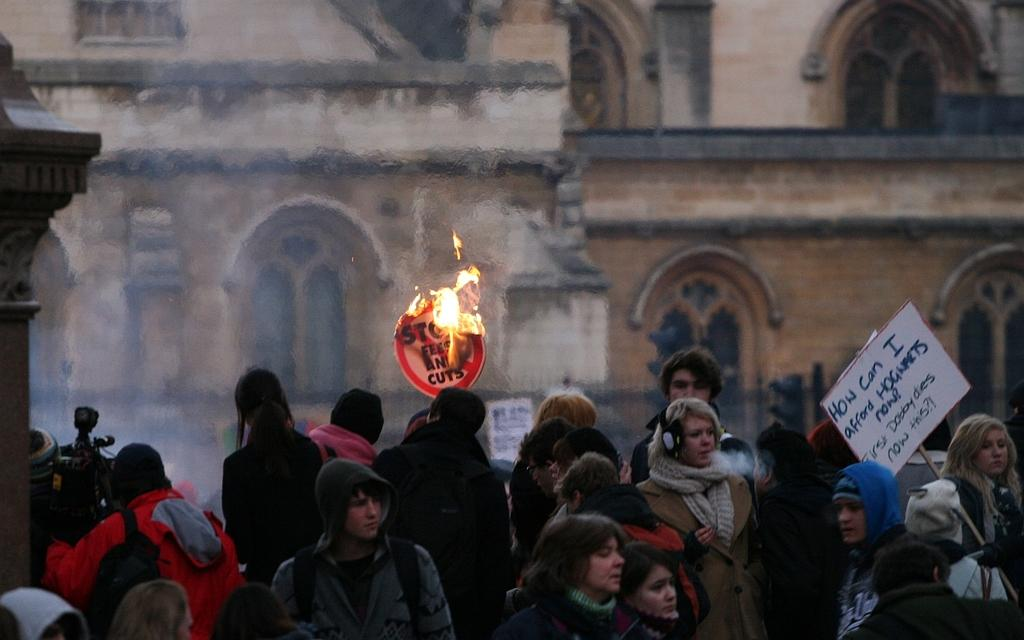Who or what is present in the image? There are people in the image. What objects can be seen in the image? There are boards in the image. What is happening in the image? There is fire in the image. What can be seen in the background of the image? There is a building and smoke in the background of the image. What type of yarn is being used by the giraffe in the image? There is no giraffe or yarn present in the image. 